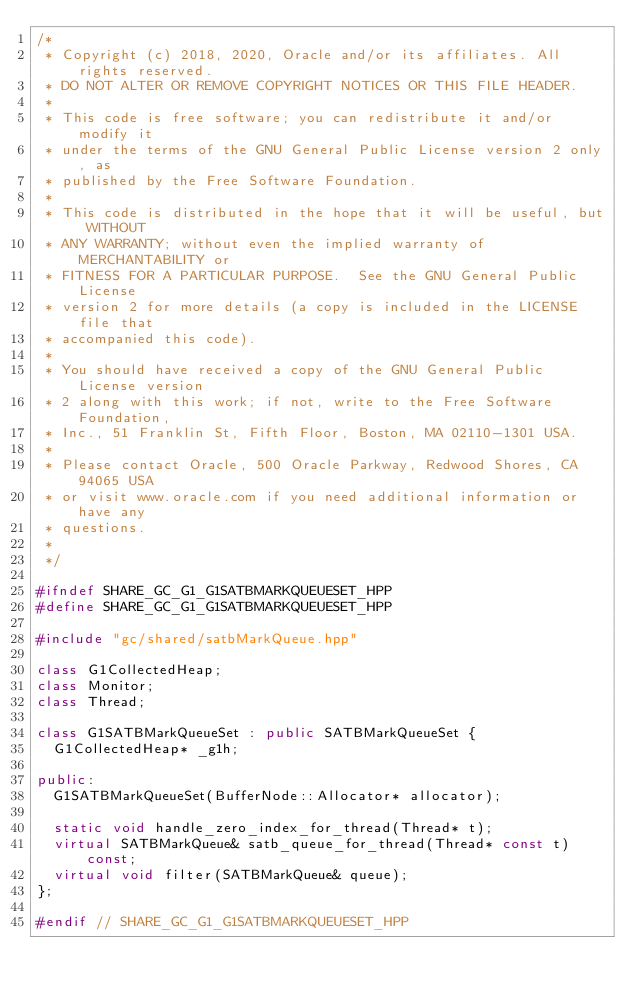<code> <loc_0><loc_0><loc_500><loc_500><_C++_>/*
 * Copyright (c) 2018, 2020, Oracle and/or its affiliates. All rights reserved.
 * DO NOT ALTER OR REMOVE COPYRIGHT NOTICES OR THIS FILE HEADER.
 *
 * This code is free software; you can redistribute it and/or modify it
 * under the terms of the GNU General Public License version 2 only, as
 * published by the Free Software Foundation.
 *
 * This code is distributed in the hope that it will be useful, but WITHOUT
 * ANY WARRANTY; without even the implied warranty of MERCHANTABILITY or
 * FITNESS FOR A PARTICULAR PURPOSE.  See the GNU General Public License
 * version 2 for more details (a copy is included in the LICENSE file that
 * accompanied this code).
 *
 * You should have received a copy of the GNU General Public License version
 * 2 along with this work; if not, write to the Free Software Foundation,
 * Inc., 51 Franklin St, Fifth Floor, Boston, MA 02110-1301 USA.
 *
 * Please contact Oracle, 500 Oracle Parkway, Redwood Shores, CA 94065 USA
 * or visit www.oracle.com if you need additional information or have any
 * questions.
 *
 */

#ifndef SHARE_GC_G1_G1SATBMARKQUEUESET_HPP
#define SHARE_GC_G1_G1SATBMARKQUEUESET_HPP

#include "gc/shared/satbMarkQueue.hpp"

class G1CollectedHeap;
class Monitor;
class Thread;

class G1SATBMarkQueueSet : public SATBMarkQueueSet {
  G1CollectedHeap* _g1h;

public:
  G1SATBMarkQueueSet(BufferNode::Allocator* allocator);

  static void handle_zero_index_for_thread(Thread* t);
  virtual SATBMarkQueue& satb_queue_for_thread(Thread* const t) const;
  virtual void filter(SATBMarkQueue& queue);
};

#endif // SHARE_GC_G1_G1SATBMARKQUEUESET_HPP
</code> 